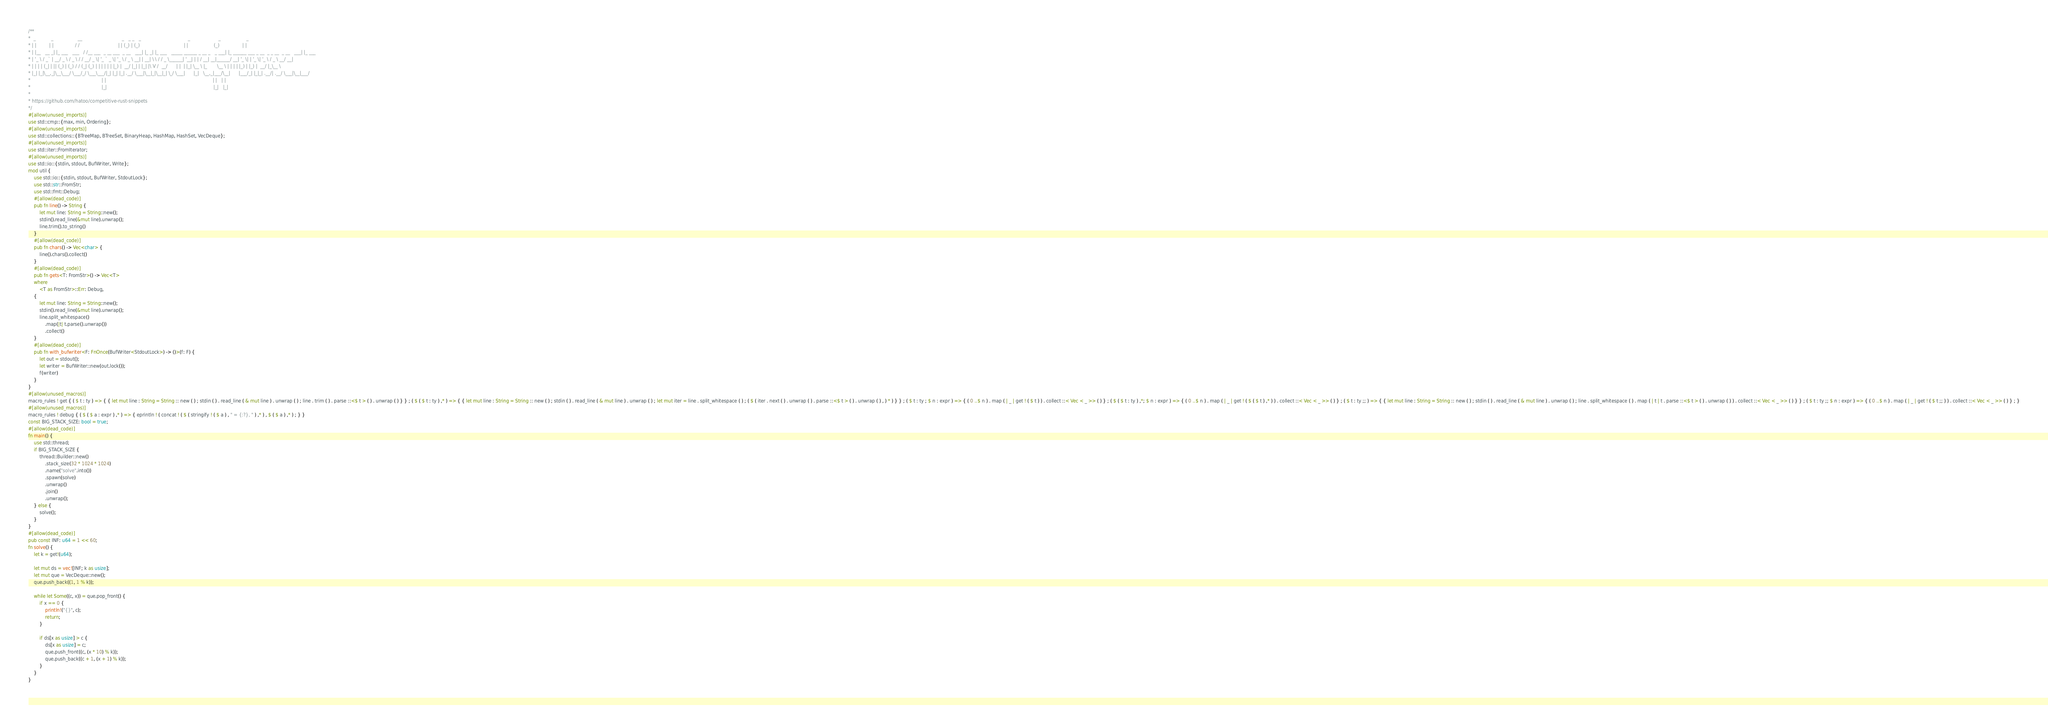Convert code to text. <code><loc_0><loc_0><loc_500><loc_500><_Rust_>/**
*  _           _                 __                            _   _ _   _                                 _                    _                  _
* | |         | |               / /                           | | (_) | (_)                               | |                  (_)                | |
* | |__   __ _| |_ ___   ___   / /__ ___  _ __ ___  _ __   ___| |_ _| |_ ___   _____ ______ _ __ _   _ ___| |_ ______ ___ _ __  _ _ __  _ __   ___| |_ ___
* | '_ \ / _` | __/ _ \ / _ \ / / __/ _ \| '_ ` _ \| '_ \ / _ \ __| | __| \ \ / / _ \______| '__| | | / __| __|______/ __| '_ \| | '_ \| '_ \ / _ \ __/ __|
* | | | | (_| | || (_) | (_) / / (_| (_) | | | | | | |_) |  __/ |_| | |_| |\ V /  __/      | |  | |_| \__ \ |_       \__ \ | | | | |_) | |_) |  __/ |_\__ \
* |_| |_|\__,_|\__\___/ \___/_/ \___\___/|_| |_| |_| .__/ \___|\__|_|\__|_| \_/ \___|      |_|   \__,_|___/\__|      |___/_| |_|_| .__/| .__/ \___|\__|___/
*                                                  | |                                                                           | |   | |
*                                                  |_|                                                                           |_|   |_|
*
* https://github.com/hatoo/competitive-rust-snippets
*/
#[allow(unused_imports)]
use std::cmp::{max, min, Ordering};
#[allow(unused_imports)]
use std::collections::{BTreeMap, BTreeSet, BinaryHeap, HashMap, HashSet, VecDeque};
#[allow(unused_imports)]
use std::iter::FromIterator;
#[allow(unused_imports)]
use std::io::{stdin, stdout, BufWriter, Write};
mod util {
    use std::io::{stdin, stdout, BufWriter, StdoutLock};
    use std::str::FromStr;
    use std::fmt::Debug;
    #[allow(dead_code)]
    pub fn line() -> String {
        let mut line: String = String::new();
        stdin().read_line(&mut line).unwrap();
        line.trim().to_string()
    }
    #[allow(dead_code)]
    pub fn chars() -> Vec<char> {
        line().chars().collect()
    }
    #[allow(dead_code)]
    pub fn gets<T: FromStr>() -> Vec<T>
    where
        <T as FromStr>::Err: Debug,
    {
        let mut line: String = String::new();
        stdin().read_line(&mut line).unwrap();
        line.split_whitespace()
            .map(|t| t.parse().unwrap())
            .collect()
    }
    #[allow(dead_code)]
    pub fn with_bufwriter<F: FnOnce(BufWriter<StdoutLock>) -> ()>(f: F) {
        let out = stdout();
        let writer = BufWriter::new(out.lock());
        f(writer)
    }
}
#[allow(unused_macros)]
macro_rules ! get { ( $ t : ty ) => { { let mut line : String = String :: new ( ) ; stdin ( ) . read_line ( & mut line ) . unwrap ( ) ; line . trim ( ) . parse ::<$ t > ( ) . unwrap ( ) } } ; ( $ ( $ t : ty ) ,* ) => { { let mut line : String = String :: new ( ) ; stdin ( ) . read_line ( & mut line ) . unwrap ( ) ; let mut iter = line . split_whitespace ( ) ; ( $ ( iter . next ( ) . unwrap ( ) . parse ::<$ t > ( ) . unwrap ( ) , ) * ) } } ; ( $ t : ty ; $ n : expr ) => { ( 0 ..$ n ) . map ( | _ | get ! ( $ t ) ) . collect ::< Vec < _ >> ( ) } ; ( $ ( $ t : ty ) ,*; $ n : expr ) => { ( 0 ..$ n ) . map ( | _ | get ! ( $ ( $ t ) ,* ) ) . collect ::< Vec < _ >> ( ) } ; ( $ t : ty ;; ) => { { let mut line : String = String :: new ( ) ; stdin ( ) . read_line ( & mut line ) . unwrap ( ) ; line . split_whitespace ( ) . map ( | t | t . parse ::<$ t > ( ) . unwrap ( ) ) . collect ::< Vec < _ >> ( ) } } ; ( $ t : ty ;; $ n : expr ) => { ( 0 ..$ n ) . map ( | _ | get ! ( $ t ;; ) ) . collect ::< Vec < _ >> ( ) } ; }
#[allow(unused_macros)]
macro_rules ! debug { ( $ ( $ a : expr ) ,* ) => { eprintln ! ( concat ! ( $ ( stringify ! ( $ a ) , " = {:?}, " ) ,* ) , $ ( $ a ) ,* ) ; } }
const BIG_STACK_SIZE: bool = true;
#[allow(dead_code)]
fn main() {
    use std::thread;
    if BIG_STACK_SIZE {
        thread::Builder::new()
            .stack_size(32 * 1024 * 1024)
            .name("solve".into())
            .spawn(solve)
            .unwrap()
            .join()
            .unwrap();
    } else {
        solve();
    }
}
#[allow(dead_code)]
pub const INF: u64 = 1 << 60;
fn solve() {
    let k = get!(u64);

    let mut ds = vec![INF; k as usize];
    let mut que = VecDeque::new();
    que.push_back((1, 1 % k));

    while let Some((c, x)) = que.pop_front() {
        if x == 0 {
            println!("{}", c);
            return;
        }

        if ds[x as usize] > c {
            ds[x as usize] = c;
            que.push_front((c, (x * 10) % k));
            que.push_back((c + 1, (x + 1) % k));
        }
    }
}
</code> 